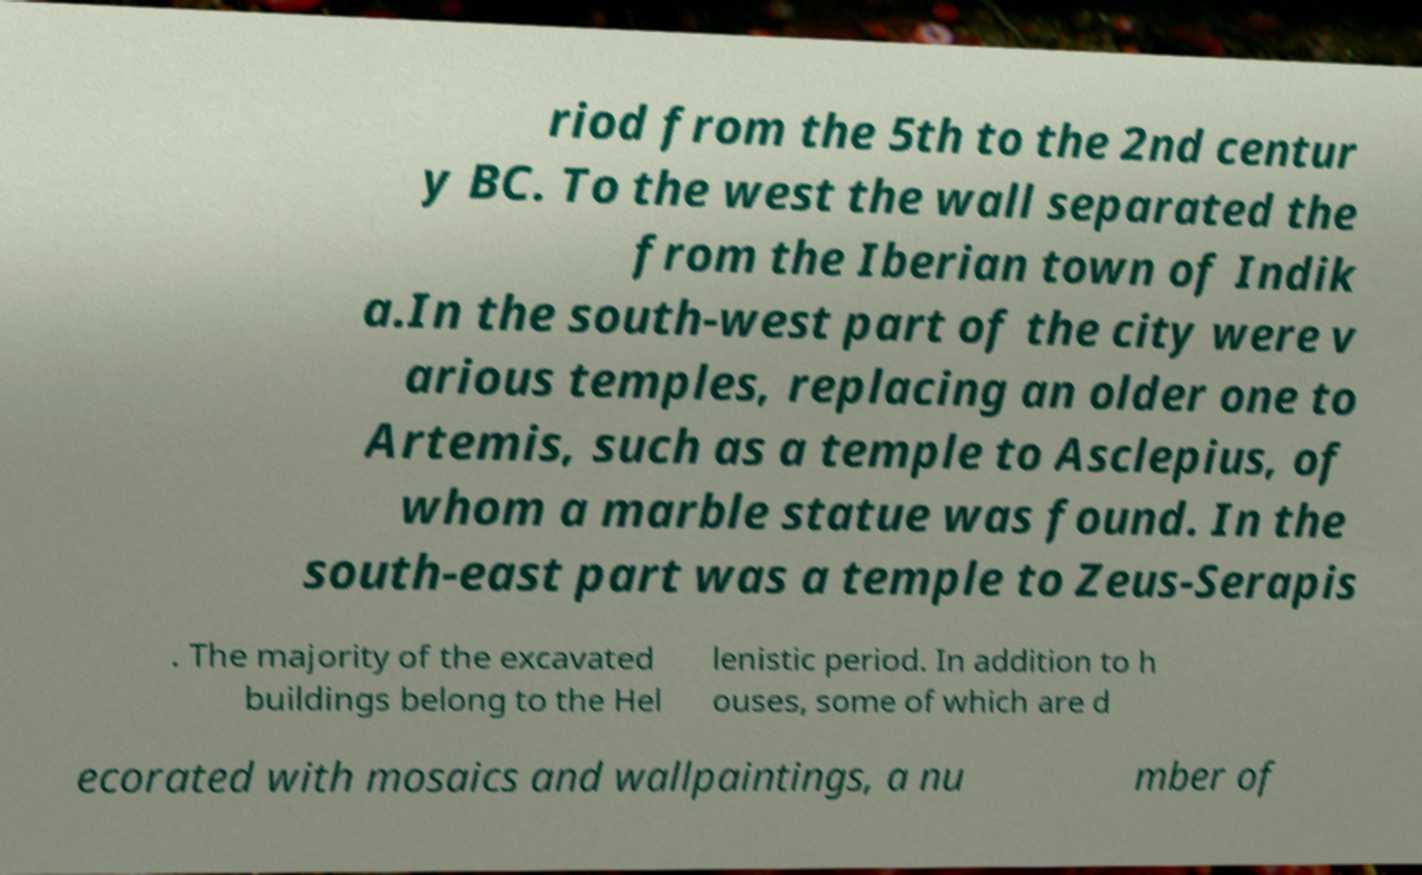Could you extract and type out the text from this image? riod from the 5th to the 2nd centur y BC. To the west the wall separated the from the Iberian town of Indik a.In the south-west part of the city were v arious temples, replacing an older one to Artemis, such as a temple to Asclepius, of whom a marble statue was found. In the south-east part was a temple to Zeus-Serapis . The majority of the excavated buildings belong to the Hel lenistic period. In addition to h ouses, some of which are d ecorated with mosaics and wallpaintings, a nu mber of 